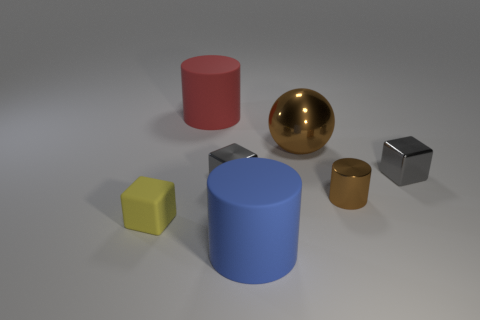Add 1 red cylinders. How many objects exist? 8 Subtract all rubber cubes. How many cubes are left? 2 Subtract all purple cylinders. How many gray blocks are left? 2 Subtract 1 cylinders. How many cylinders are left? 2 Subtract all cubes. How many objects are left? 4 Subtract all gray cubes. Subtract all small matte things. How many objects are left? 4 Add 7 blue rubber cylinders. How many blue rubber cylinders are left? 8 Add 2 large brown cylinders. How many large brown cylinders exist? 2 Subtract 0 cyan cylinders. How many objects are left? 7 Subtract all purple cubes. Subtract all yellow cylinders. How many cubes are left? 3 